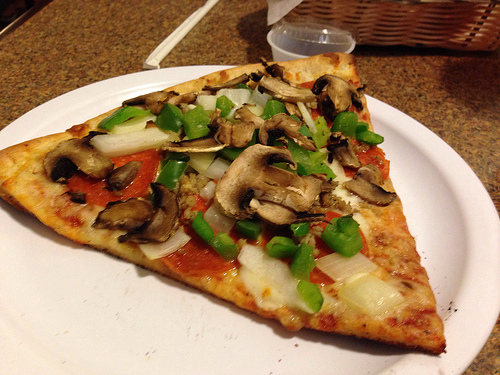Please provide the bounding box coordinate of the region this sentence describes: the fresh green bell pepper. The specified region containing a fresh green bell pepper can be found within the coordinates [0.38, 0.54, 0.73, 0.68]. 